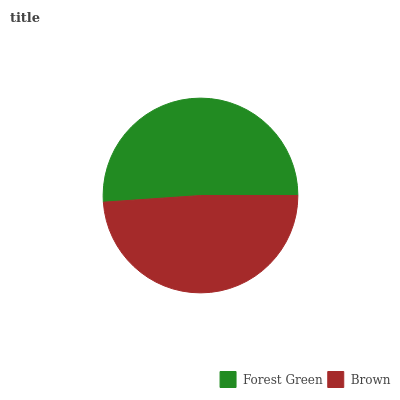Is Brown the minimum?
Answer yes or no. Yes. Is Forest Green the maximum?
Answer yes or no. Yes. Is Brown the maximum?
Answer yes or no. No. Is Forest Green greater than Brown?
Answer yes or no. Yes. Is Brown less than Forest Green?
Answer yes or no. Yes. Is Brown greater than Forest Green?
Answer yes or no. No. Is Forest Green less than Brown?
Answer yes or no. No. Is Forest Green the high median?
Answer yes or no. Yes. Is Brown the low median?
Answer yes or no. Yes. Is Brown the high median?
Answer yes or no. No. Is Forest Green the low median?
Answer yes or no. No. 